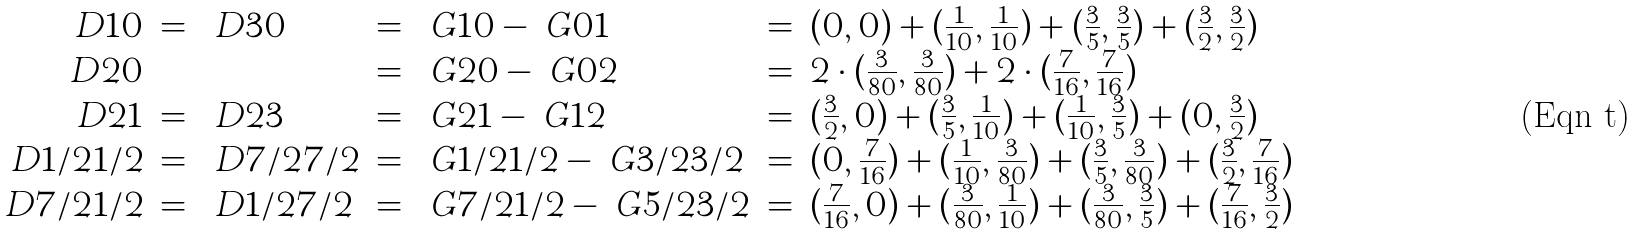<formula> <loc_0><loc_0><loc_500><loc_500>\begin{array} { r c l c l c l } \ D { 1 } { 0 } & = & \ D { 3 } { 0 } & = & \ G { 1 } { 0 } - \ G { 0 } { 1 } & = & ( 0 , 0 ) + ( \frac { 1 } { 1 0 } , \frac { 1 } { 1 0 } ) + ( \frac { 3 } { 5 } , \frac { 3 } { 5 } ) + ( \frac { 3 } { 2 } , \frac { 3 } { 2 } ) \\ \ D { 2 } { 0 } & & & = & \ G { 2 } { 0 } - \ G { 0 } { 2 } & = & 2 \cdot ( \frac { 3 } { 8 0 } , \frac { 3 } { 8 0 } ) + 2 \cdot ( \frac { 7 } { 1 6 } , \frac { 7 } { 1 6 } ) \\ \ D { 2 } { 1 } & = & \ D { 2 } { 3 } & = & \ G { 2 } { 1 } - \ G { 1 } { 2 } & = & ( \frac { 3 } { 2 } , 0 ) + ( \frac { 3 } { 5 } , \frac { 1 } { 1 0 } ) + ( \frac { 1 } { 1 0 } , \frac { 3 } { 5 } ) + ( 0 , \frac { 3 } { 2 } ) \\ \ D { 1 / 2 } { 1 / 2 } & = & \ D { 7 / 2 } { 7 / 2 } & = & \ G { 1 / 2 } { 1 / 2 } - \ G { 3 / 2 } { 3 / 2 } & = & ( 0 , \frac { 7 } { 1 6 } ) + ( \frac { 1 } { 1 0 } , \frac { 3 } { 8 0 } ) + ( \frac { 3 } { 5 } , \frac { 3 } { 8 0 } ) + ( \frac { 3 } { 2 } , \frac { 7 } { 1 6 } ) \\ \ D { 7 / 2 } { 1 / 2 } & = & \ D { 1 / 2 } { 7 / 2 } & = & \ G { 7 / 2 } { 1 / 2 } - \ G { 5 / 2 } { 3 / 2 } & = & ( \frac { 7 } { 1 6 } , 0 ) + ( \frac { 3 } { 8 0 } , \frac { 1 } { 1 0 } ) + ( \frac { 3 } { 8 0 } , \frac { 3 } { 5 } ) + ( \frac { 7 } { 1 6 } , \frac { 3 } { 2 } ) \end{array}</formula> 